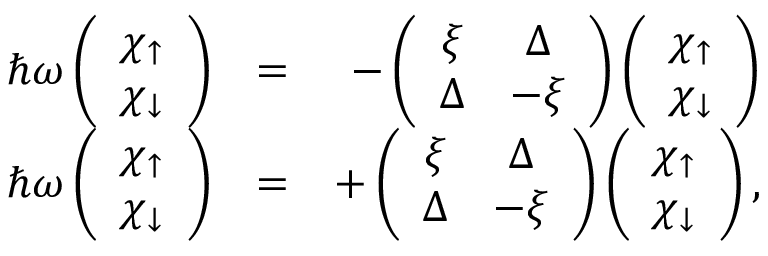Convert formula to latex. <formula><loc_0><loc_0><loc_500><loc_500>\begin{array} { r l r } { \hbar { \omega } \left ( \begin{array} { c } { \chi _ { \uparrow } } \\ { \chi _ { \downarrow } } \end{array} \right ) } & { = } & { - \left ( \begin{array} { c c } { \xi } & { \Delta } \\ { \Delta } & { - \xi } \end{array} \right ) \left ( \begin{array} { c } { \chi _ { \uparrow } } \\ { \chi _ { \downarrow } } \end{array} \right ) } \\ { \hbar { \omega } \left ( \begin{array} { c } { \chi _ { \uparrow } } \\ { \chi _ { \downarrow } } \end{array} \right ) } & { = } & { + \left ( \begin{array} { c c } { \xi } & { \Delta } \\ { \Delta } & { - \xi } \end{array} \right ) \left ( \begin{array} { c } { \chi _ { \uparrow } } \\ { \chi _ { \downarrow } } \end{array} \right ) , } \end{array}</formula> 